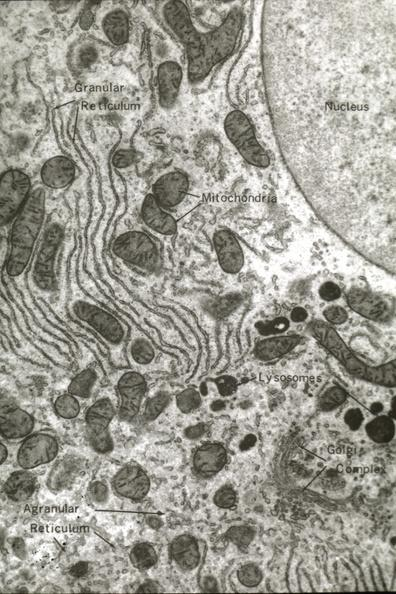what is present?
Answer the question using a single word or phrase. Hepatobiliary 